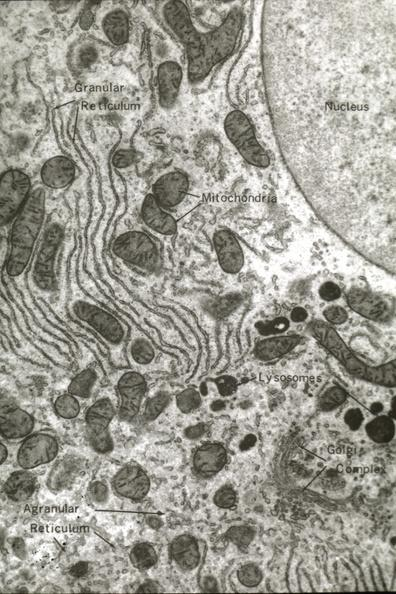what is present?
Answer the question using a single word or phrase. Hepatobiliary 